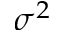<formula> <loc_0><loc_0><loc_500><loc_500>\sigma ^ { 2 }</formula> 